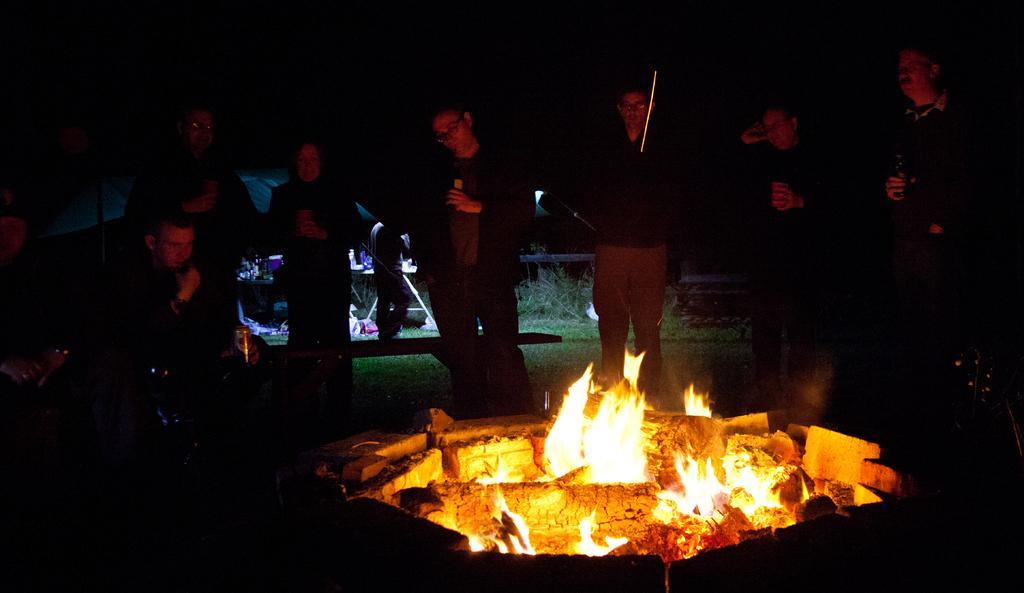Describe this image in one or two sentences. In this image we can see a few people holding the objects, in front of them, we can see the fire, behind them, we can see a table with some objects on it and the background is dark. 